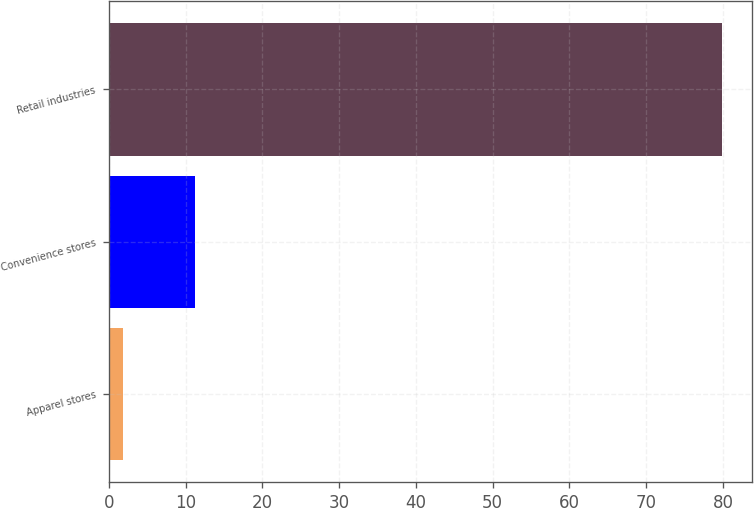Convert chart to OTSL. <chart><loc_0><loc_0><loc_500><loc_500><bar_chart><fcel>Apparel stores<fcel>Convenience stores<fcel>Retail industries<nl><fcel>1.9<fcel>11.2<fcel>79.8<nl></chart> 